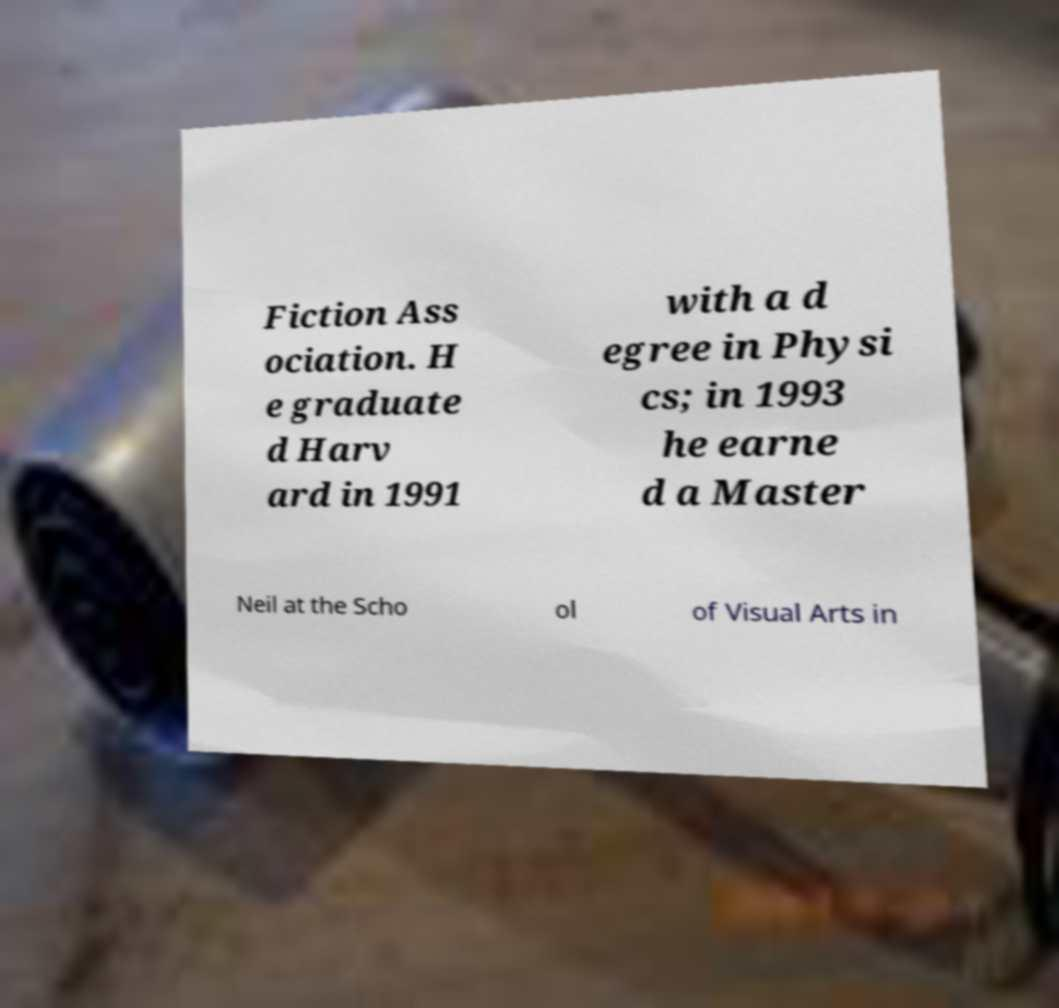I need the written content from this picture converted into text. Can you do that? Fiction Ass ociation. H e graduate d Harv ard in 1991 with a d egree in Physi cs; in 1993 he earne d a Master Neil at the Scho ol of Visual Arts in 